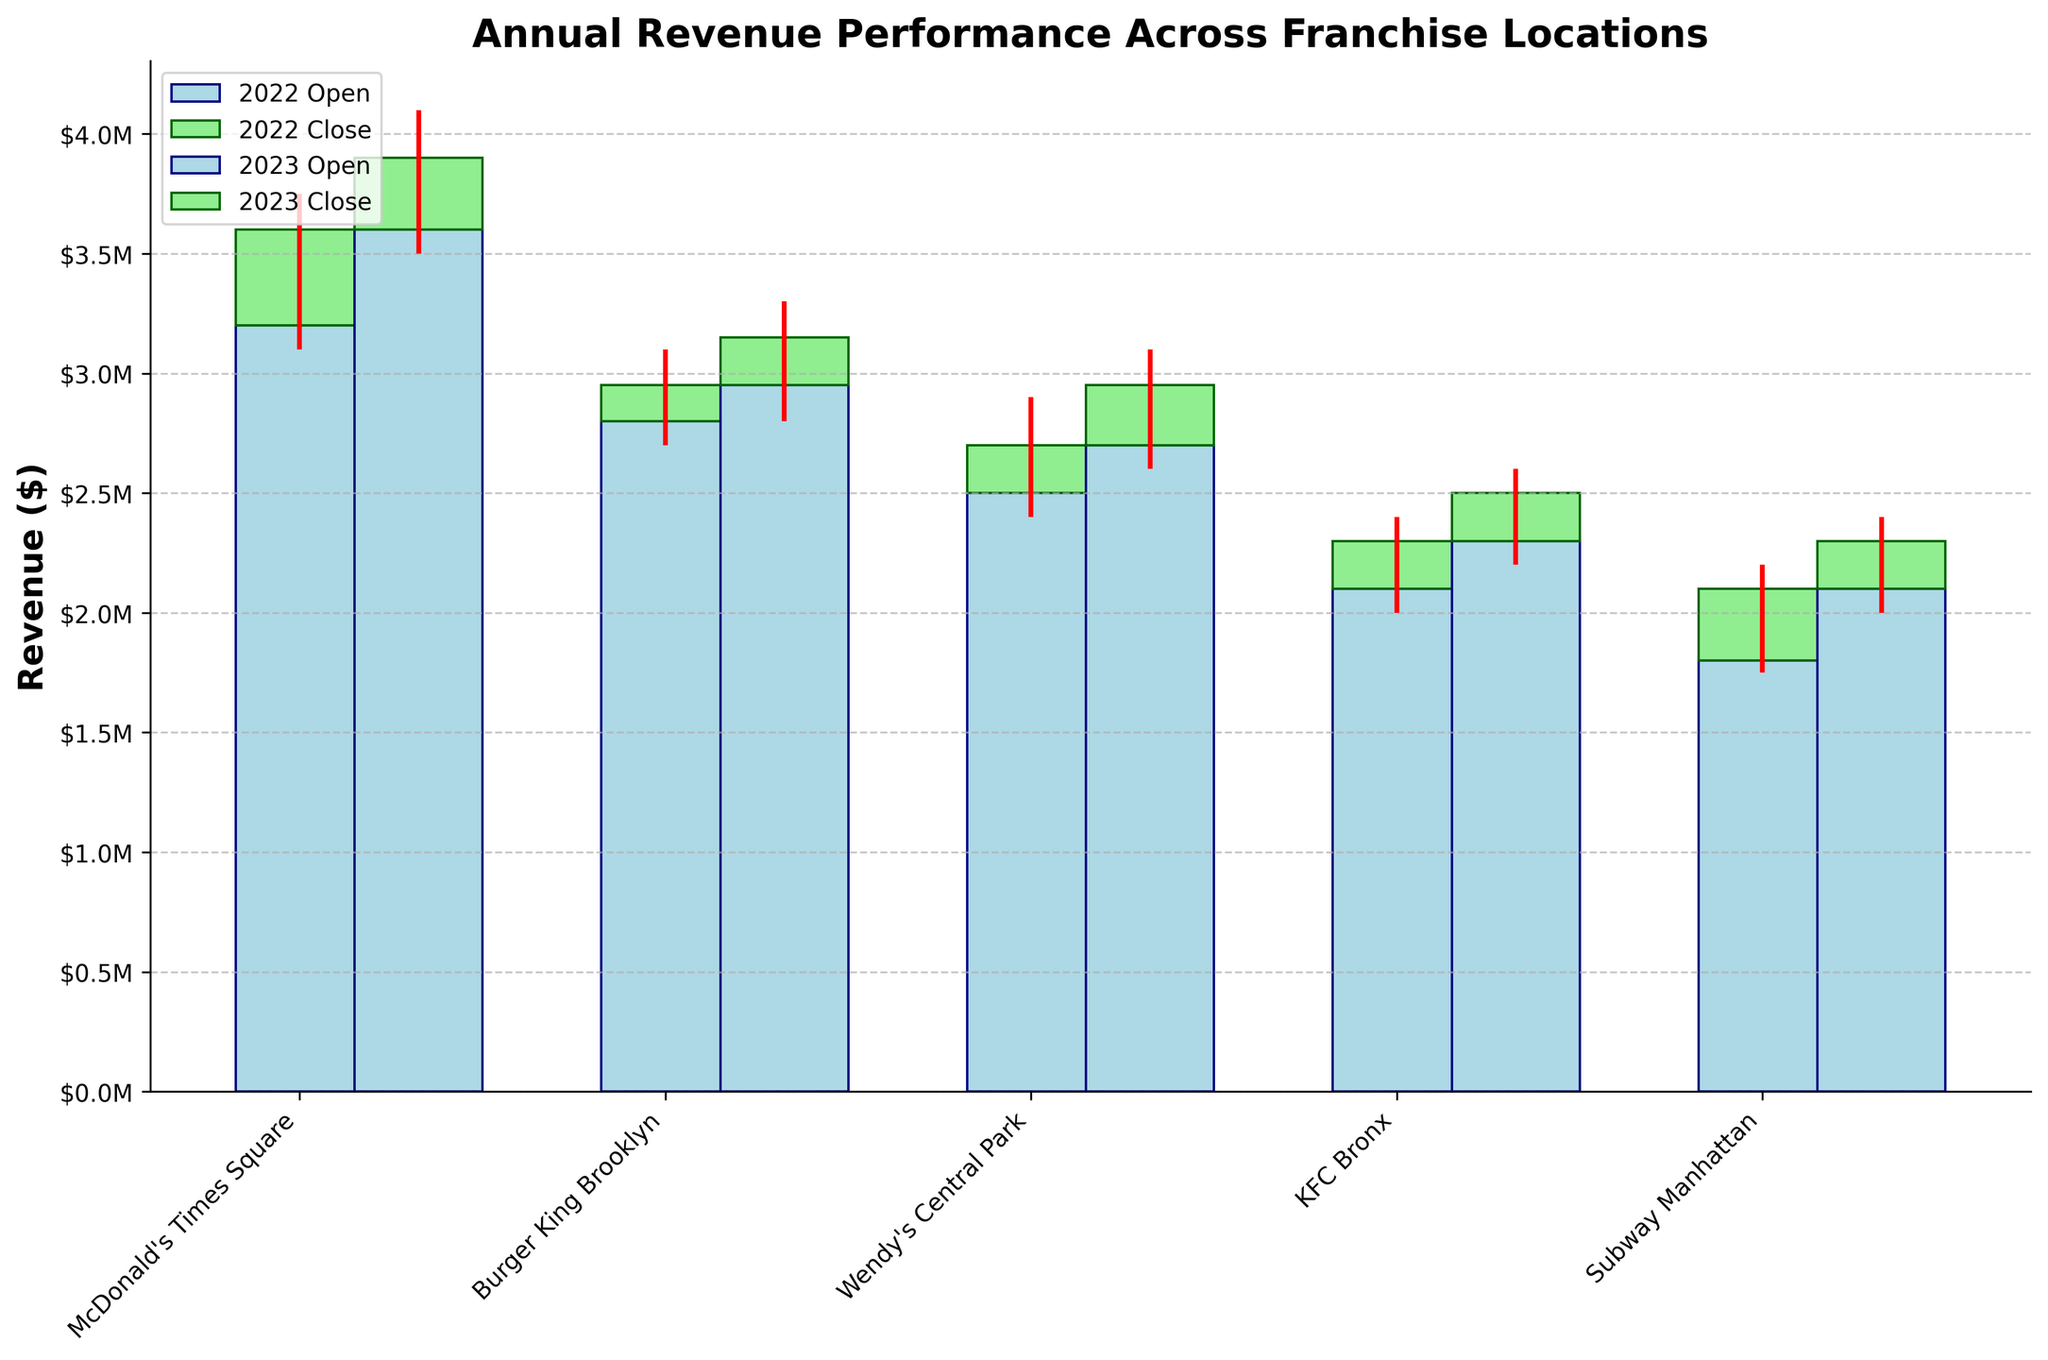What is the highest revenue recorded by McDonald's Times Square in the given years? The high value for McDonald's Times Square in 2023 is $4,100,000.
Answer: $4,100,000 How does the closing revenue for Subway Manhattan in 2023 compare to 2022? The closing revenue for Subway Manhattan in 2022 is $2,100,000, and in 2023 it is $2,300,000. The revenue increased by $200,000.
Answer: Increased by $200,000 Which location had the lowest revenue in 2022, and what was the amount? The lowest revenue in 2022 is recorded by Subway Manhattan at $1,750,000 (Low value).
Answer: Subway Manhattan, $1,750,000 What is the average closing revenue for KFC Bronx across the two years? The closing revenue for KFC Bronx in 2022 is $2,300,000 and in 2023 is $2,500,000. The average is (2,300,000 + 2,500,000) / 2 = $2,400,000.
Answer: $2,400,000 How did Wendy’s Central Park’s highest revenue change from 2022 to 2023? In 2022, Wendy’s Central Park recorded a high value of $2,900,000, whereas in 2023, it increased to $3,100,000.
Answer: Increased by $200,000 What is the title of the chart? The title is "Annual Revenue Performance Across Franchise Locations".
Answer: Annual Revenue Performance Across Franchise Locations Compare the opening revenues for McDonald's Times Square and Burger King Brooklyn in 2023. In 2023, McDonald's Times Square's opening revenue is $3,600,000, while Burger King Brooklyn's opening revenue is $2,950,000. McDonald's is higher by $650,000.
Answer: McDonald's Times Square is higher by $650,000 What is the difference between the lowest revenue and the highest revenue recorded for KFC Bronx in 2023? The lowest revenue for KFC Bronx in 2023 is $2,200,000, and the highest is $2,600,000. The difference is $2,600,000 - $2,200,000 = $400,000.
Answer: $400,000 How did the opening revenue for McDonald's Times Square change from 2022 to 2023? The opening revenue for McDonald's Times Square in 2022 is $3,200,000, while in 2023 it is $3,600,000. The revenue increased by $400,000.
Answer: Increased by $400,000 